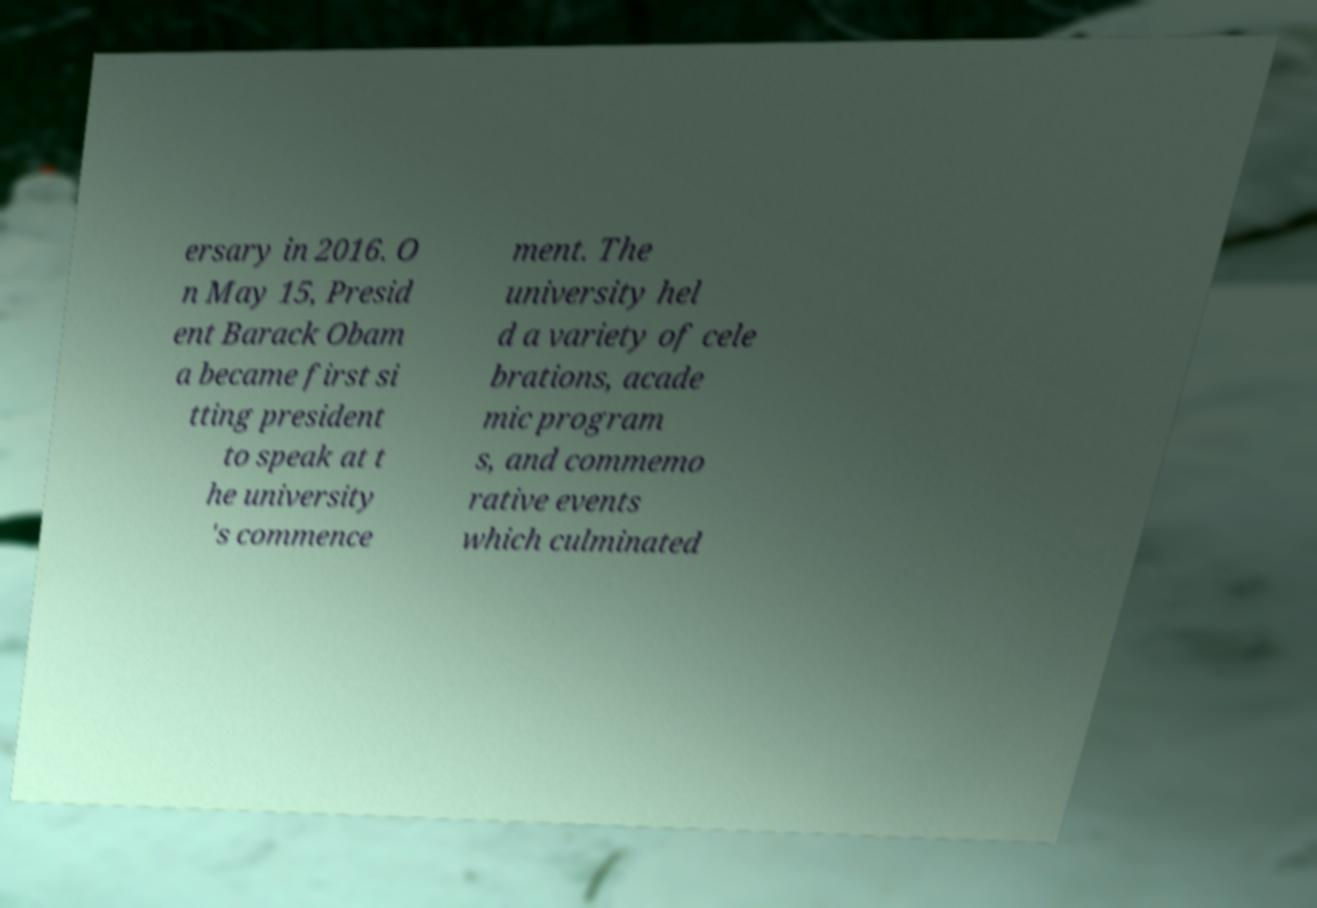What messages or text are displayed in this image? I need them in a readable, typed format. ersary in 2016. O n May 15, Presid ent Barack Obam a became first si tting president to speak at t he university 's commence ment. The university hel d a variety of cele brations, acade mic program s, and commemo rative events which culminated 